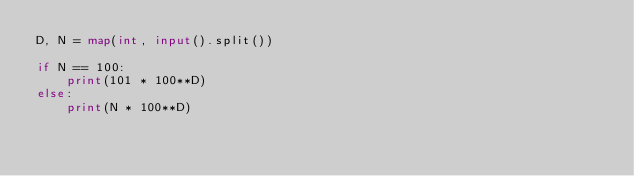<code> <loc_0><loc_0><loc_500><loc_500><_Python_>D, N = map(int, input().split())

if N == 100:
    print(101 * 100**D)
else:
    print(N * 100**D)
</code> 